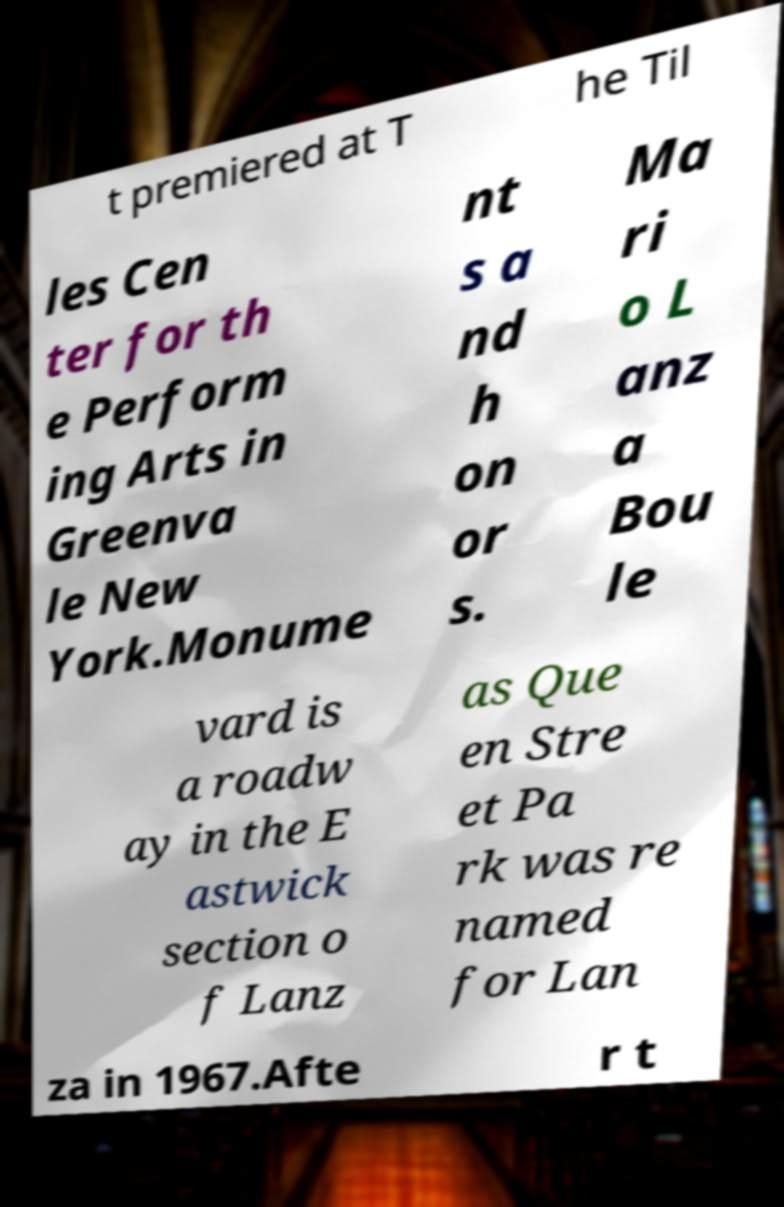I need the written content from this picture converted into text. Can you do that? t premiered at T he Til les Cen ter for th e Perform ing Arts in Greenva le New York.Monume nt s a nd h on or s. Ma ri o L anz a Bou le vard is a roadw ay in the E astwick section o f Lanz as Que en Stre et Pa rk was re named for Lan za in 1967.Afte r t 